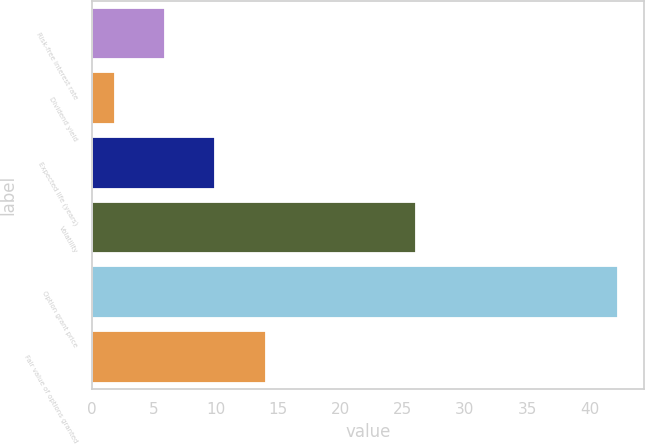Convert chart to OTSL. <chart><loc_0><loc_0><loc_500><loc_500><bar_chart><fcel>Risk-free interest rate<fcel>Dividend yield<fcel>Expected life (years)<fcel>Volatility<fcel>Option grant price<fcel>Fair value of options granted<nl><fcel>5.9<fcel>1.86<fcel>9.94<fcel>26.09<fcel>42.3<fcel>13.98<nl></chart> 